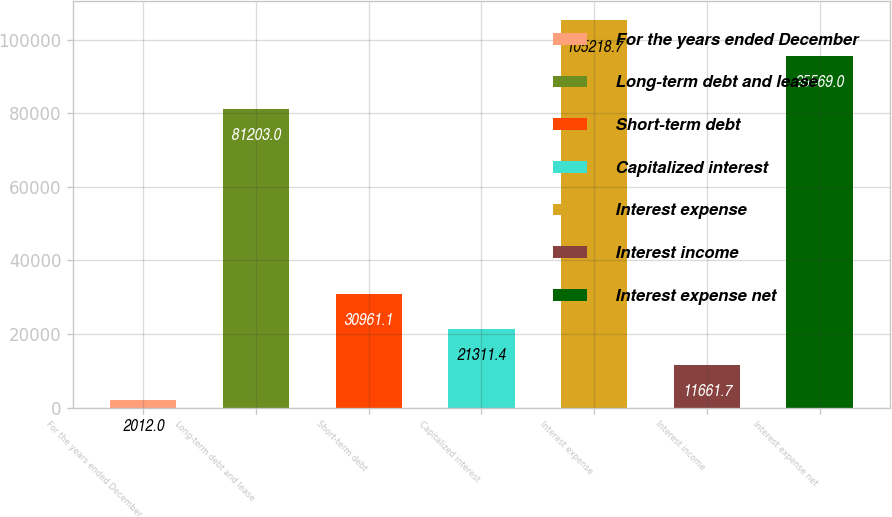Convert chart. <chart><loc_0><loc_0><loc_500><loc_500><bar_chart><fcel>For the years ended December<fcel>Long-term debt and lease<fcel>Short-term debt<fcel>Capitalized interest<fcel>Interest expense<fcel>Interest income<fcel>Interest expense net<nl><fcel>2012<fcel>81203<fcel>30961.1<fcel>21311.4<fcel>105219<fcel>11661.7<fcel>95569<nl></chart> 